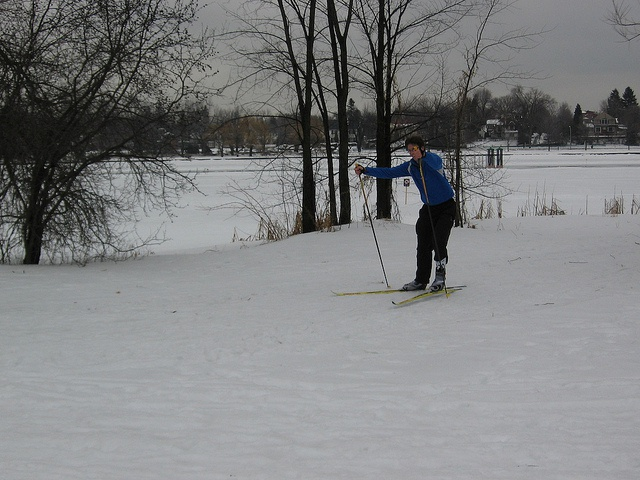Describe the objects in this image and their specific colors. I can see people in gray, black, navy, and darkgray tones and skis in gray, olive, and darkgray tones in this image. 